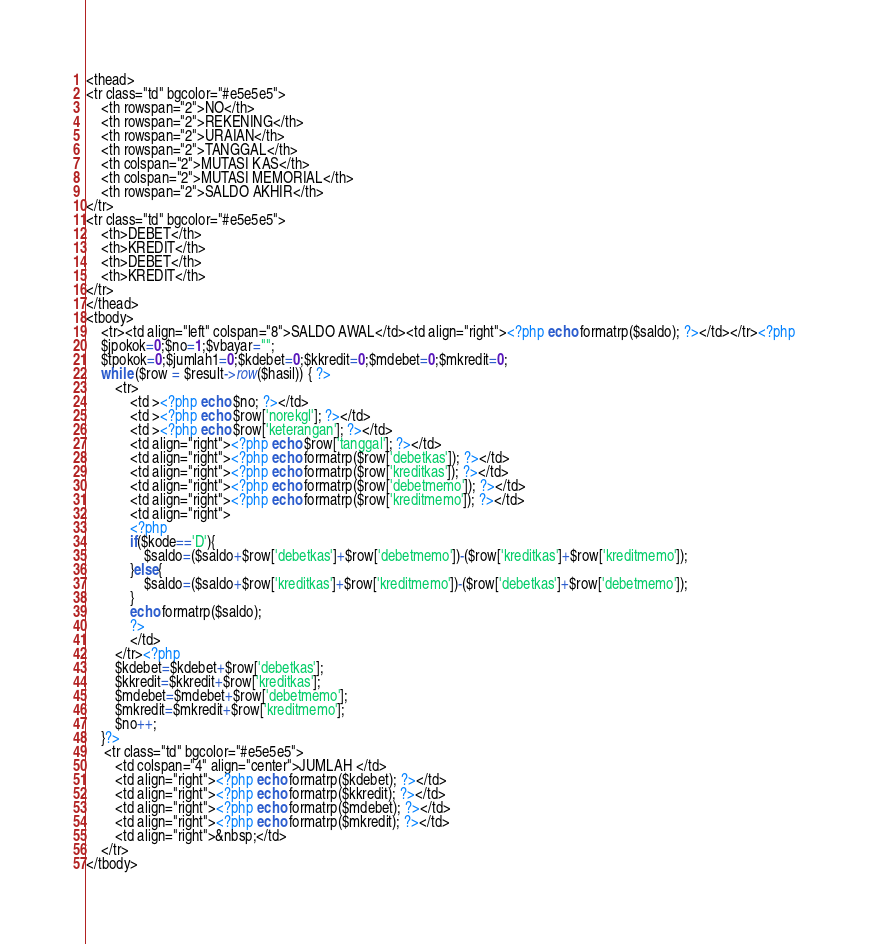Convert code to text. <code><loc_0><loc_0><loc_500><loc_500><_PHP_><thead>
<tr class="td" bgcolor="#e5e5e5">
	<th rowspan="2">NO</th>
	<th rowspan="2">REKENING</th>
	<th rowspan="2">URAIAN</th>
	<th rowspan="2">TANGGAL</th>
	<th colspan="2">MUTASI KAS</th>
	<th colspan="2">MUTASI MEMORIAL</th>
	<th rowspan="2">SALDO AKHIR</th>
</tr>
<tr class="td" bgcolor="#e5e5e5">
	<th>DEBET</th>
	<th>KREDIT</th>
	<th>DEBET</th>
	<th>KREDIT</th>
</tr>
</thead>
<tbody>
	<tr><td align="left" colspan="8">SALDO AWAL</td><td align="right"><?php echo formatrp($saldo); ?></td></tr><?php 
	$jpokok=0;$no=1;$vbayar="";
	$tpokok=0;$jumlah1=0;$kdebet=0;$kkredit=0;$mdebet=0;$mkredit=0;
	while ($row = $result->row($hasil)) { ?>
		<tr>
			<td ><?php echo $no; ?></td>
			<td ><?php echo $row['norekgl']; ?></td>
			<td ><?php echo $row['keterangan']; ?></td>
			<td align="right"><?php echo $row['tanggal']; ?></td>
			<td align="right"><?php echo formatrp($row['debetkas']); ?></td>
			<td align="right"><?php echo formatrp($row['kreditkas']); ?></td>
			<td align="right"><?php echo formatrp($row['debetmemo']); ?></td>
			<td align="right"><?php echo formatrp($row['kreditmemo']); ?></td>
			<td align="right">
			<?php 
			if($kode=='D'){
				$saldo=($saldo+$row['debetkas']+$row['debetmemo'])-($row['kreditkas']+$row['kreditmemo']);
			}else{
				$saldo=($saldo+$row['kreditkas']+$row['kreditmemo'])-($row['debetkas']+$row['debetmemo']);
			}
			echo formatrp($saldo); 
			?>
			</td>
		</tr><?php 
		$kdebet=$kdebet+$row['debetkas'];
		$kkredit=$kkredit+$row['kreditkas'];
		$mdebet=$mdebet+$row['debetmemo'];
		$mkredit=$mkredit+$row['kreditmemo'];
		$no++;
	}?>
	 <tr class="td" bgcolor="#e5e5e5">
		<td colspan="4" align="center">JUMLAH </td>
		<td align="right"><?php echo formatrp($kdebet); ?></td>
		<td align="right"><?php echo formatrp($kkredit); ?></td>
		<td align="right"><?php echo formatrp($mdebet); ?></td>
		<td align="right"><?php echo formatrp($mkredit); ?></td>
		<td align="right">&nbsp;</td>
	</tr>
</tbody>
</code> 